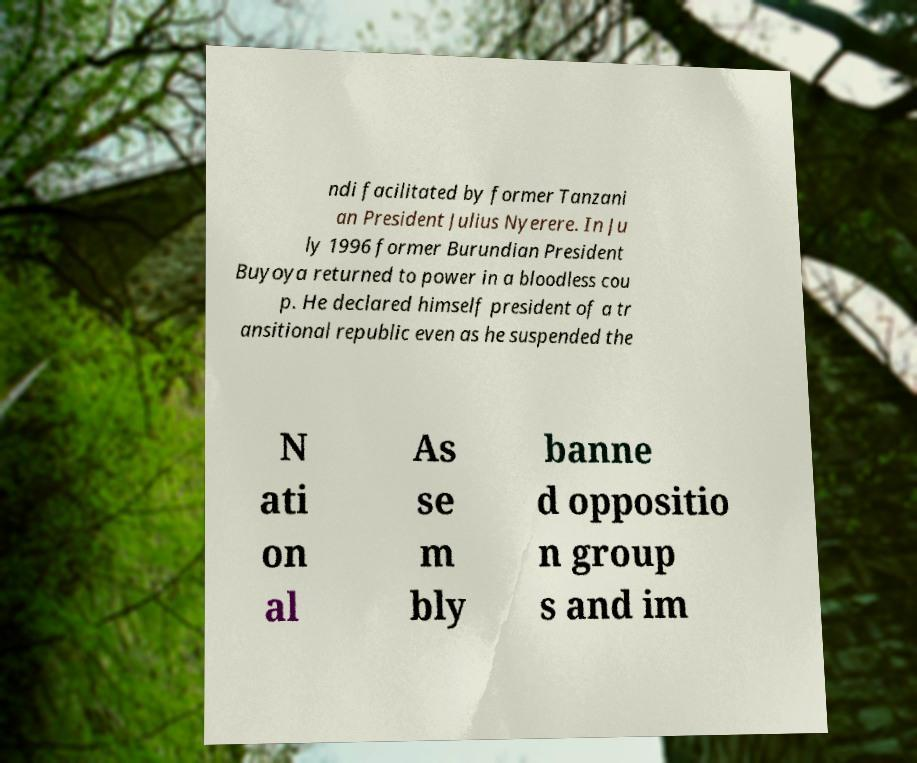Please identify and transcribe the text found in this image. ndi facilitated by former Tanzani an President Julius Nyerere. In Ju ly 1996 former Burundian President Buyoya returned to power in a bloodless cou p. He declared himself president of a tr ansitional republic even as he suspended the N ati on al As se m bly banne d oppositio n group s and im 